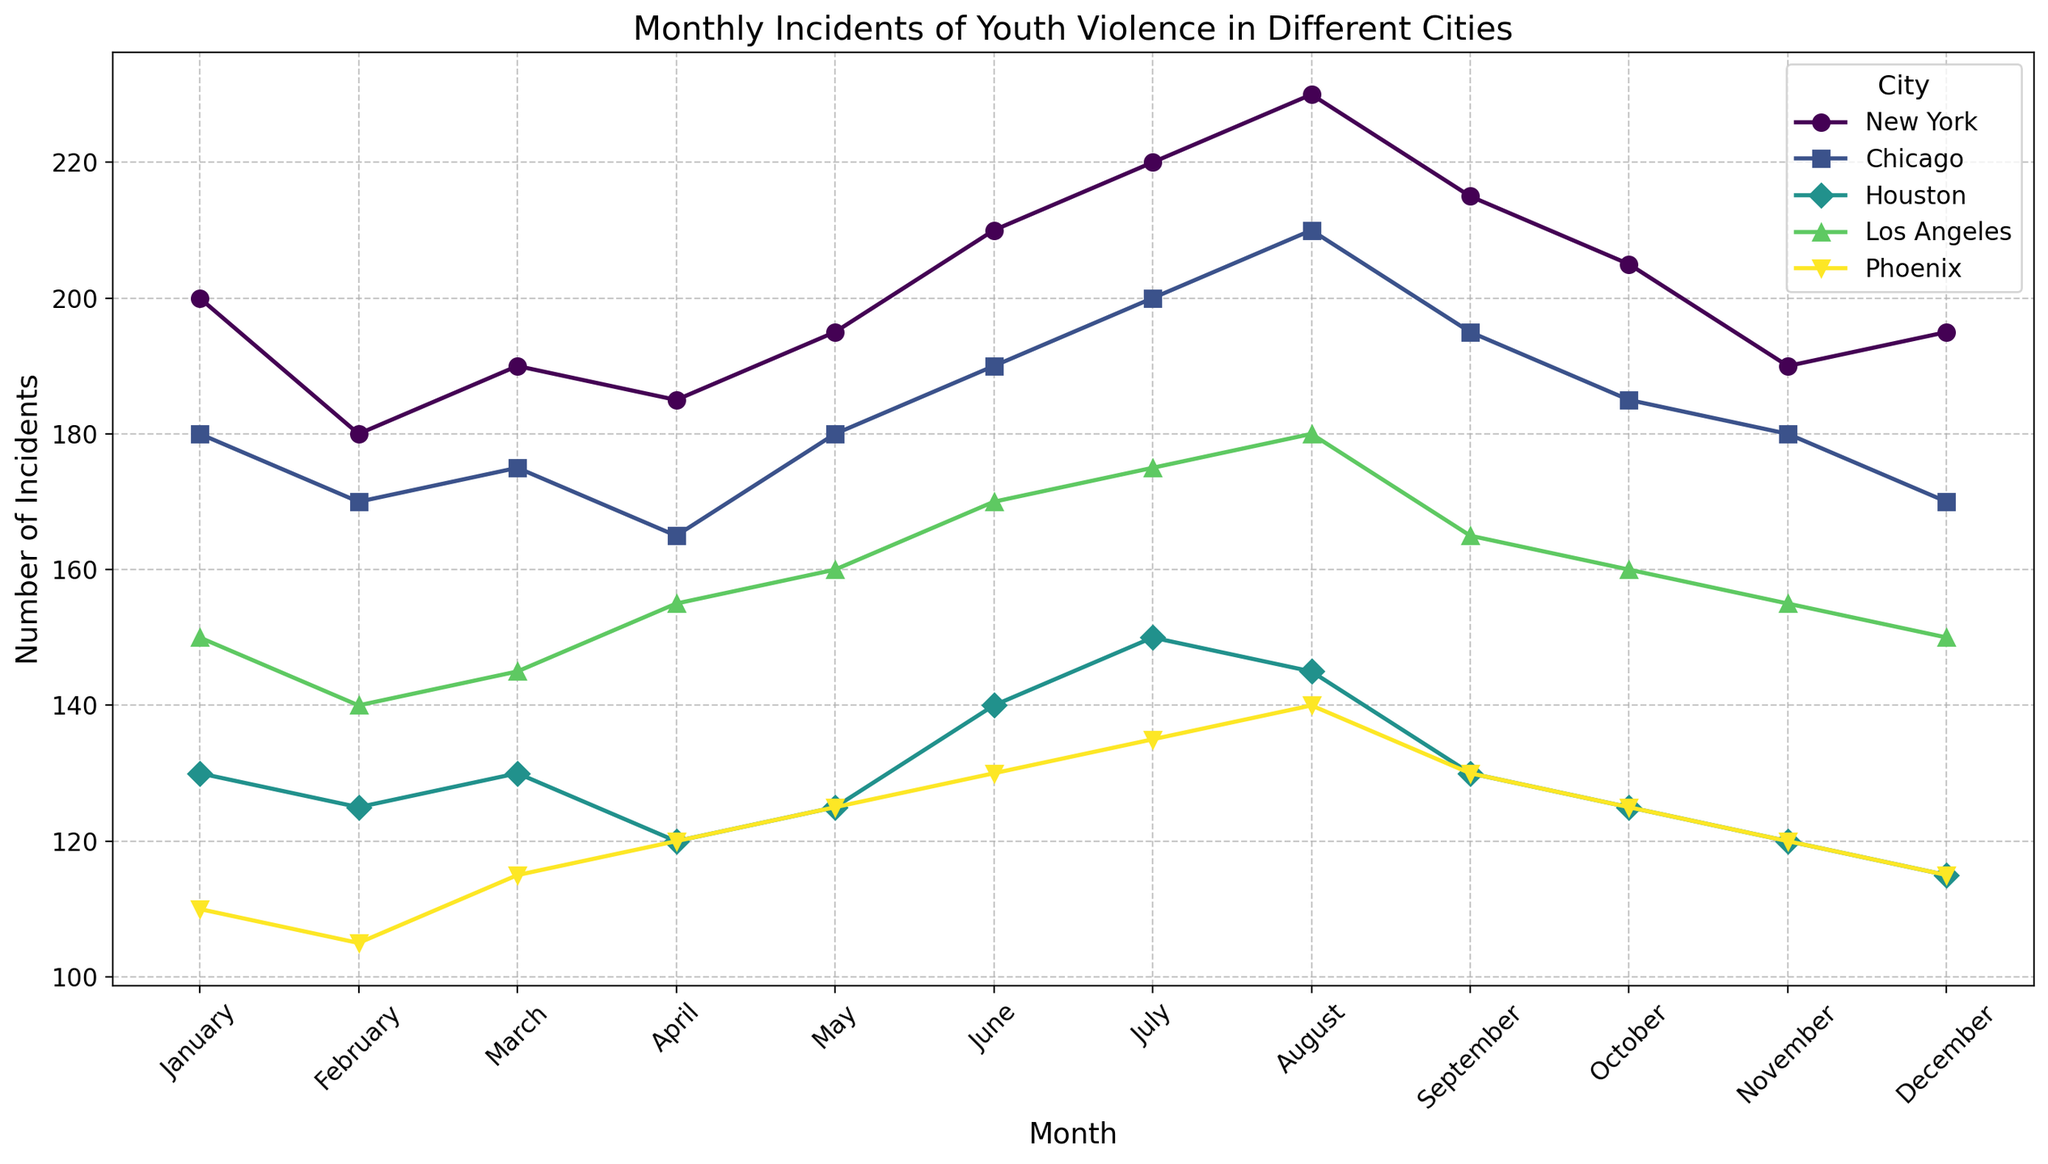what is the city with the highest number of youth violence incidents in August? To determine the city with the highest incidents in August, check the line representing August for all cities and identify the one with the highest value. New York has 230, Los Angeles has 180, Chicago has 210, Houston has 145, Phoenix has 140. So New York has the highest.
Answer: New York Which city shows the most significant decrease in youth violence incidents from September to December? Look at the points for September and December for each city and find the difference. New York decreases from 215 to 195 (20), Los Angeles from 165 to 150 (15), Chicago from 195 to 170 (25), Houston from 130 to 115 (15), Phoenix from 130 to 115 (15). So, Chicago has the most significant decrease.
Answer: Chicago How many total incidents of youth violence were recorded in all cities combined in July? Sum the incidents for July across all cities. New York has 220, Los Angeles has 175, Chicago has 200, Houston has 150, Phoenix has 135. The total is 220 + 175 + 200 + 150 + 135 = 880.
Answer: 880 Which city shows a trend of increasing youth violence incidents from January to July? Assess the trends from January to July for each city. New York goes from 200 to 220 (increasing), Los Angeles from 150 to 175 (increasing), Chicago from 180 to 200 (increasing), Houston from 130 to 150 (increasing), and Phoenix from 110 to 135 (increasing). Thus, all cities show increasing trends.
Answer: All cities Between which two consecutive months does New York show the most significant increase in youth violence incidents? Calculate the difference between consecutive months for New York and find the month with the highest increase. February to March is 10 (190-180), May to June is 15 (210-195), June to July is 10 (220-210), July to August is 10 (230-220), August to September is 15 (230-215). So, February to March has the largest increase.
Answer: February to March 